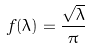<formula> <loc_0><loc_0><loc_500><loc_500>f ( \lambda ) = \frac { \sqrt { \lambda } } { \pi }</formula> 